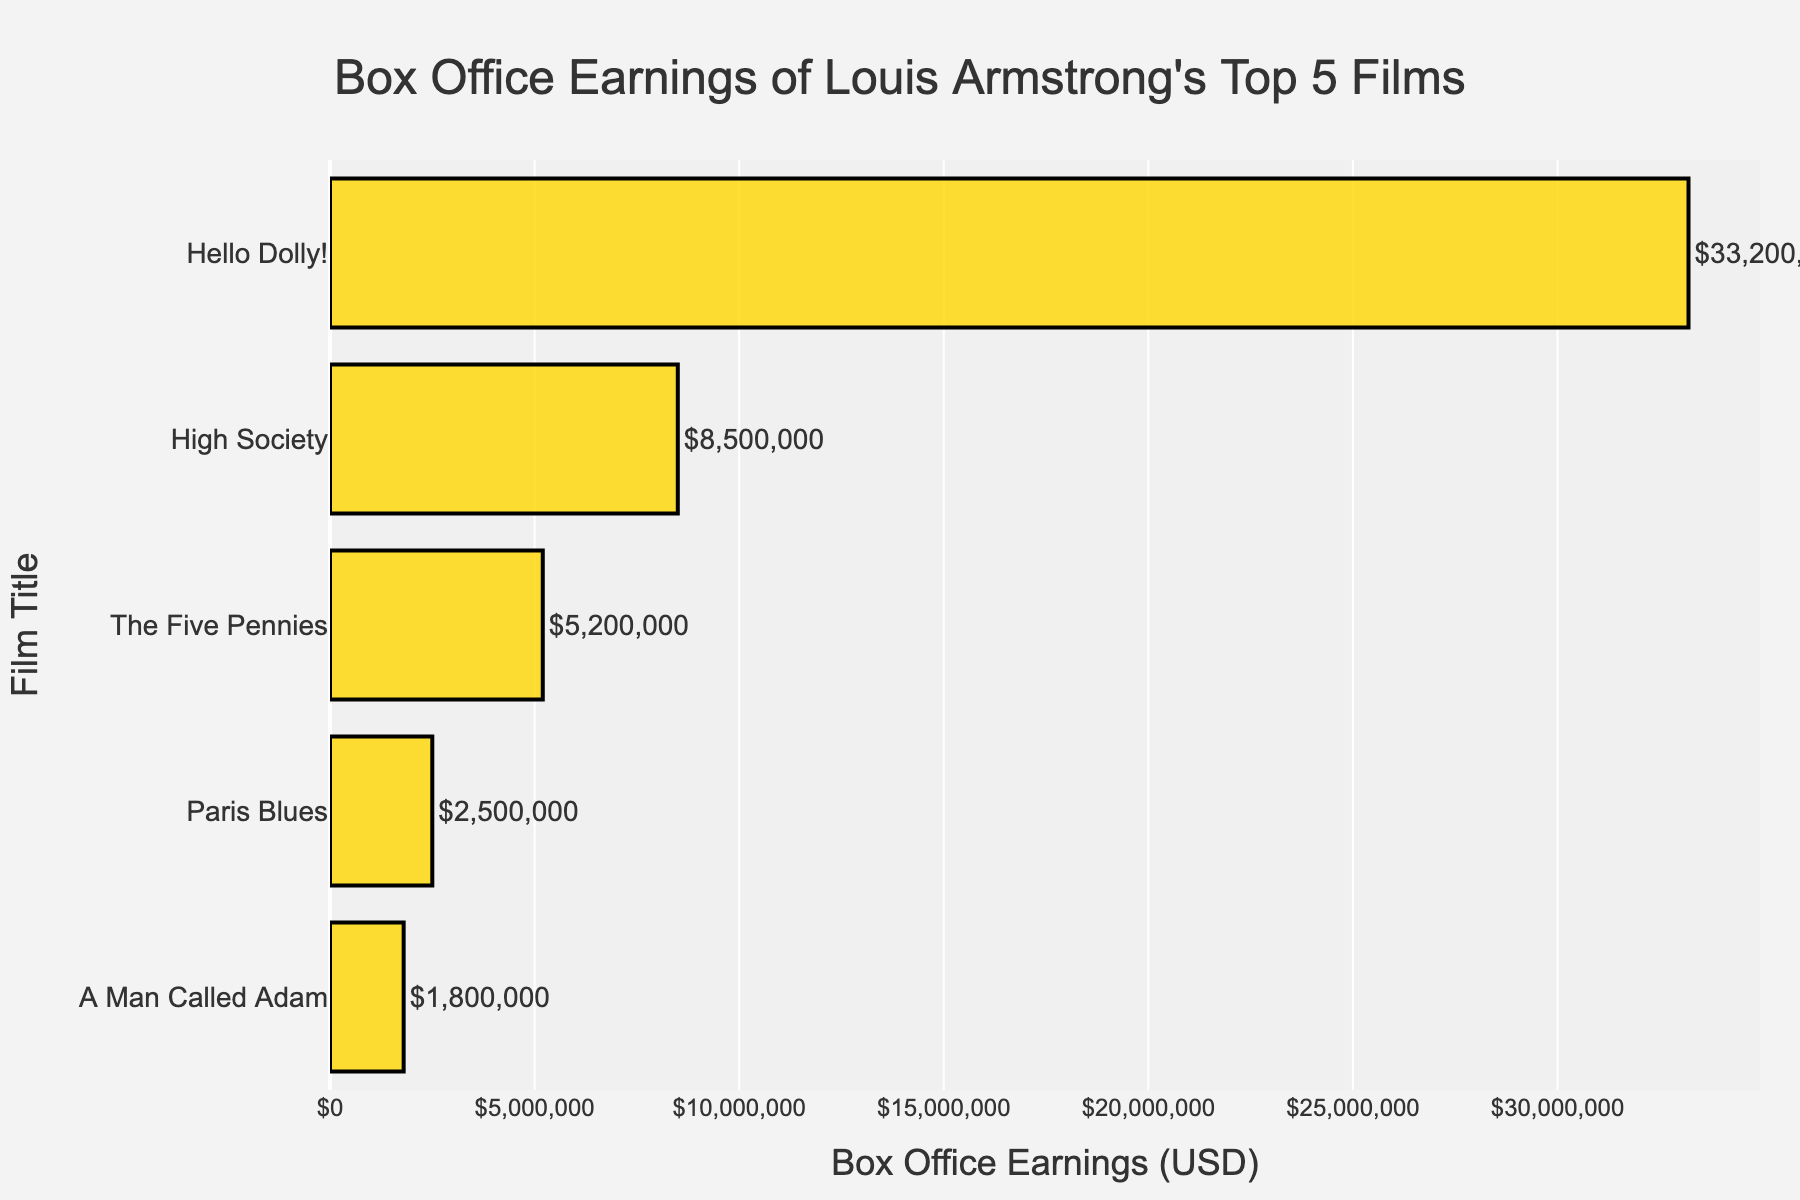Which film earned the most at the box office? Hello Dolly! has the highest value shown on the bar chart.
Answer: Hello Dolly! Which film is the lowest earner at the box office? The smallest bar represents "A Man Called Adam," indicating the lowest earnings.
Answer: A Man Called Adam How much more did "The Five Pennies" earn compared to "Paris Blues"? "The Five Pennies" earned $5,200,000 and "Paris Blues" earned $2,500,000. The difference is $5,200,000 - $2,500,000 = $2,700,000.
Answer: $2,700,000 What's the total box office earnings for all five films? Sum the earnings: $8,500,000 + $5,200,000 + $33,200,000 + $2,500,000 + $1,800,000 = $51,200,000.
Answer: $51,200,000 Which film earned more on average, "High Society" or "Paris Blues"? "High Society": $8,500,000; "Paris Blues": $2,500,000. So, $8,500,000 > $2,500,000.
Answer: High Society What’s the dollar difference between the highest and lowest earners? Highest: $33,200,000 (Hello Dolly!). Lowest: $1,800,000 (A Man Called Adam). Difference: $33,200,000 - $1,800,000 = $31,400,000.
Answer: $31,400,000 Which films earned less than $5,000,000 at the box office? Films with earnings below $5,000,000 are "Paris Blues" ($2,500,000) and "A Man Called Adam" ($1,800,000).
Answer: Paris Blues, A Man Called Adam Is the length of the bar for "Hello Dolly!" more than twice that of "High Society"? The earnings for "Hello Dolly!" are $33,200,000, and for "High Society," it is $8,500,000. $33,200,000 is indeed more than twice $8,500,000.
Answer: Yes 